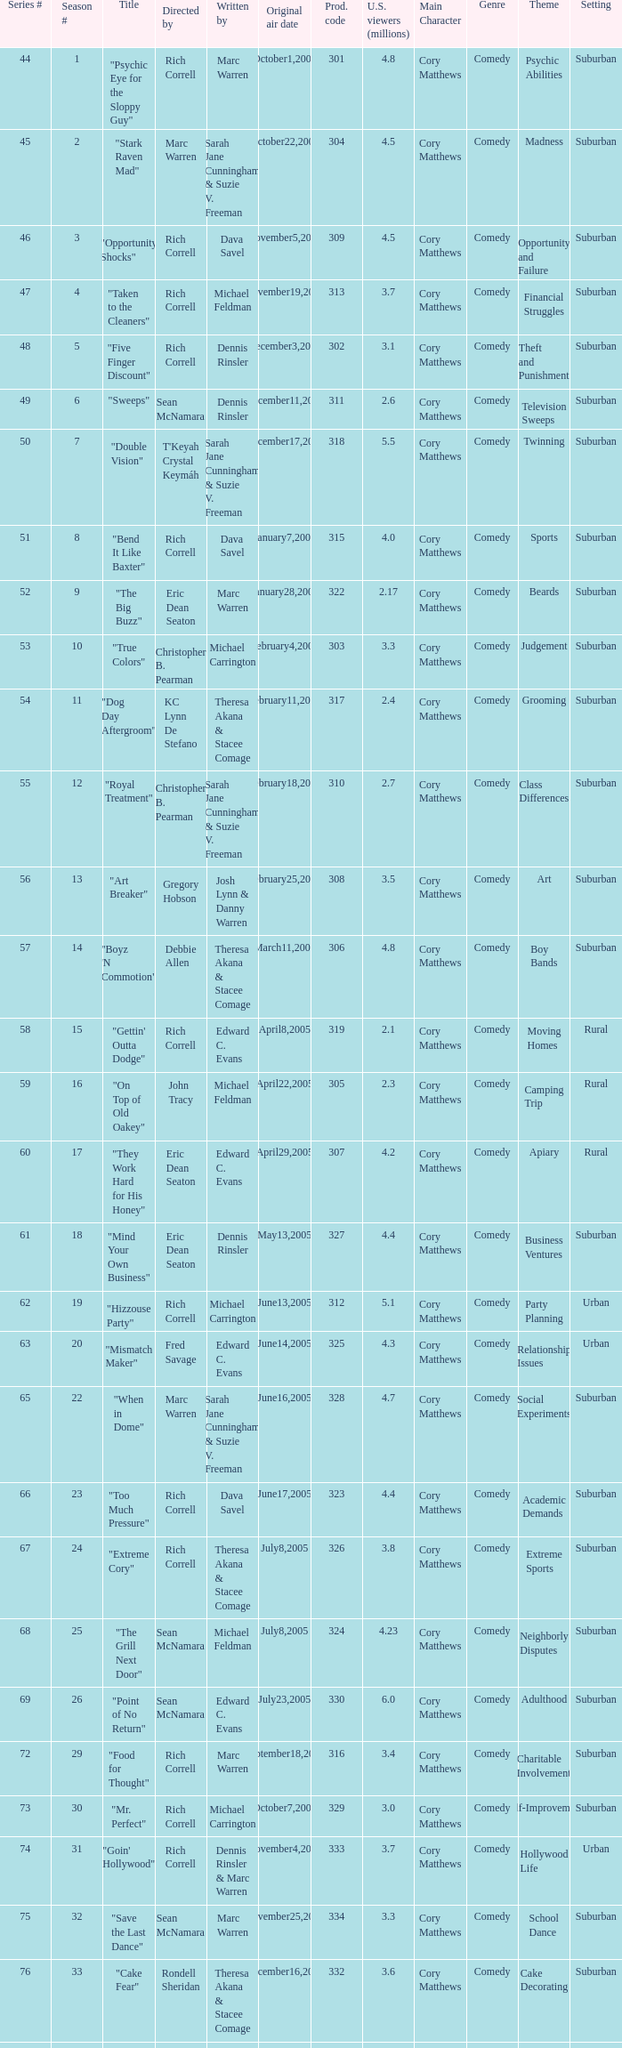Would you mind parsing the complete table? {'header': ['Series #', 'Season #', 'Title', 'Directed by', 'Written by', 'Original air date', 'Prod. code', 'U.S. viewers (millions)', 'Main Character', 'Genre', 'Theme', 'Setting'], 'rows': [['44', '1', '"Psychic Eye for the Sloppy Guy"', 'Rich Correll', 'Marc Warren', 'October1,2004', '301', '4.8', 'Cory Matthews', 'Comedy', 'Psychic Abilities', 'Suburban'], ['45', '2', '"Stark Raven Mad"', 'Marc Warren', 'Sarah Jane Cunningham & Suzie V. Freeman', 'October22,2004', '304', '4.5', 'Cory Matthews', 'Comedy', 'Madness', 'Suburban'], ['46', '3', '"Opportunity Shocks"', 'Rich Correll', 'Dava Savel', 'November5,2004', '309', '4.5', 'Cory Matthews', 'Comedy', 'Opportunity and Failure', 'Suburban'], ['47', '4', '"Taken to the Cleaners"', 'Rich Correll', 'Michael Feldman', 'November19,2004', '313', '3.7', 'Cory Matthews', 'Comedy', 'Financial Struggles', 'Suburban'], ['48', '5', '"Five Finger Discount"', 'Rich Correll', 'Dennis Rinsler', 'December3,2004', '302', '3.1', 'Cory Matthews', 'Comedy', 'Theft and Punishment', 'Suburban'], ['49', '6', '"Sweeps"', 'Sean McNamara', 'Dennis Rinsler', 'December11,2004', '311', '2.6', 'Cory Matthews', 'Comedy', 'Television Sweeps', 'Suburban'], ['50', '7', '"Double Vision"', "T'Keyah Crystal Keymáh", 'Sarah Jane Cunningham & Suzie V. Freeman', 'December17,2004', '318', '5.5', 'Cory Matthews', 'Comedy', 'Twinning', 'Suburban'], ['51', '8', '"Bend It Like Baxter"', 'Rich Correll', 'Dava Savel', 'January7,2005', '315', '4.0', 'Cory Matthews', 'Comedy', 'Sports', 'Suburban'], ['52', '9', '"The Big Buzz"', 'Eric Dean Seaton', 'Marc Warren', 'January28,2005', '322', '2.17', 'Cory Matthews', 'Comedy', 'Beards', 'Suburban'], ['53', '10', '"True Colors"', 'Christopher B. Pearman', 'Michael Carrington', 'February4,2005', '303', '3.3', 'Cory Matthews', 'Comedy', 'Judgement', 'Suburban'], ['54', '11', '"Dog Day Aftergroom"', 'KC Lynn De Stefano', 'Theresa Akana & Stacee Comage', 'February11,2005', '317', '2.4', 'Cory Matthews', 'Comedy', 'Grooming', 'Suburban'], ['55', '12', '"Royal Treatment"', 'Christopher B. Pearman', 'Sarah Jane Cunningham & Suzie V. Freeman', 'February18,2005', '310', '2.7', 'Cory Matthews', 'Comedy', 'Class Differences', 'Suburban'], ['56', '13', '"Art Breaker"', 'Gregory Hobson', 'Josh Lynn & Danny Warren', 'February25,2005', '308', '3.5', 'Cory Matthews', 'Comedy', 'Art', 'Suburban'], ['57', '14', '"Boyz \'N Commotion"', 'Debbie Allen', 'Theresa Akana & Stacee Comage', 'March11,2005', '306', '4.8', 'Cory Matthews', 'Comedy', 'Boy Bands', 'Suburban'], ['58', '15', '"Gettin\' Outta Dodge"', 'Rich Correll', 'Edward C. Evans', 'April8,2005', '319', '2.1', 'Cory Matthews', 'Comedy', 'Moving Homes', 'Rural'], ['59', '16', '"On Top of Old Oakey"', 'John Tracy', 'Michael Feldman', 'April22,2005', '305', '2.3', 'Cory Matthews', 'Comedy', 'Camping Trip', 'Rural'], ['60', '17', '"They Work Hard for His Honey"', 'Eric Dean Seaton', 'Edward C. Evans', 'April29,2005', '307', '4.2', 'Cory Matthews', 'Comedy', 'Apiary', 'Rural'], ['61', '18', '"Mind Your Own Business"', 'Eric Dean Seaton', 'Dennis Rinsler', 'May13,2005', '327', '4.4', 'Cory Matthews', 'Comedy', 'Business Ventures', 'Suburban'], ['62', '19', '"Hizzouse Party"', 'Rich Correll', 'Michael Carrington', 'June13,2005', '312', '5.1', 'Cory Matthews', 'Comedy', 'Party Planning', 'Urban'], ['63', '20', '"Mismatch Maker"', 'Fred Savage', 'Edward C. Evans', 'June14,2005', '325', '4.3', 'Cory Matthews', 'Comedy', 'Relationship Issues', 'Urban'], ['65', '22', '"When in Dome"', 'Marc Warren', 'Sarah Jane Cunningham & Suzie V. Freeman', 'June16,2005', '328', '4.7', 'Cory Matthews', 'Comedy', 'Social Experiments', 'Suburban'], ['66', '23', '"Too Much Pressure"', 'Rich Correll', 'Dava Savel', 'June17,2005', '323', '4.4', 'Cory Matthews', 'Comedy', 'Academic Demands', 'Suburban'], ['67', '24', '"Extreme Cory"', 'Rich Correll', 'Theresa Akana & Stacee Comage', 'July8,2005', '326', '3.8', 'Cory Matthews', 'Comedy', 'Extreme Sports', 'Suburban'], ['68', '25', '"The Grill Next Door"', 'Sean McNamara', 'Michael Feldman', 'July8,2005', '324', '4.23', 'Cory Matthews', 'Comedy', 'Neighborly Disputes', 'Suburban'], ['69', '26', '"Point of No Return"', 'Sean McNamara', 'Edward C. Evans', 'July23,2005', '330', '6.0', 'Cory Matthews', 'Comedy', 'Adulthood', 'Suburban'], ['72', '29', '"Food for Thought"', 'Rich Correll', 'Marc Warren', 'September18,2005', '316', '3.4', 'Cory Matthews', 'Comedy', 'Charitable Involvement', 'Suburban'], ['73', '30', '"Mr. Perfect"', 'Rich Correll', 'Michael Carrington', 'October7,2005', '329', '3.0', 'Cory Matthews', 'Comedy', 'Self-Improvement', 'Suburban'], ['74', '31', '"Goin\' Hollywood"', 'Rich Correll', 'Dennis Rinsler & Marc Warren', 'November4,2005', '333', '3.7', 'Cory Matthews', 'Comedy', 'Hollywood Life', 'Urban'], ['75', '32', '"Save the Last Dance"', 'Sean McNamara', 'Marc Warren', 'November25,2005', '334', '3.3', 'Cory Matthews', 'Comedy', 'School Dance', 'Suburban'], ['76', '33', '"Cake Fear"', 'Rondell Sheridan', 'Theresa Akana & Stacee Comage', 'December16,2005', '332', '3.6', 'Cory Matthews', 'Comedy', 'Cake Decorating', 'Suburban'], ['77', '34', '"Vision Impossible"', 'Marc Warren', 'David Brookwell & Sean McNamara', 'January6,2006', '335', '4.7', 'Cory Matthews', 'Comedy', 'Eye Health', 'Suburban']]} What number episode of the season was titled "Vision Impossible"? 34.0. 